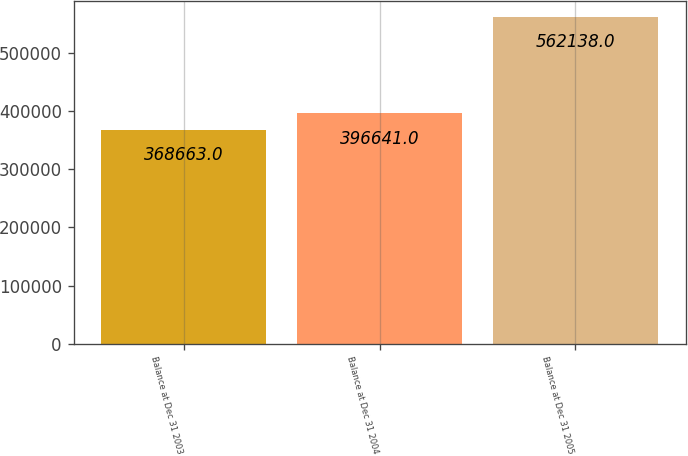Convert chart to OTSL. <chart><loc_0><loc_0><loc_500><loc_500><bar_chart><fcel>Balance at Dec 31 2003<fcel>Balance at Dec 31 2004<fcel>Balance at Dec 31 2005<nl><fcel>368663<fcel>396641<fcel>562138<nl></chart> 